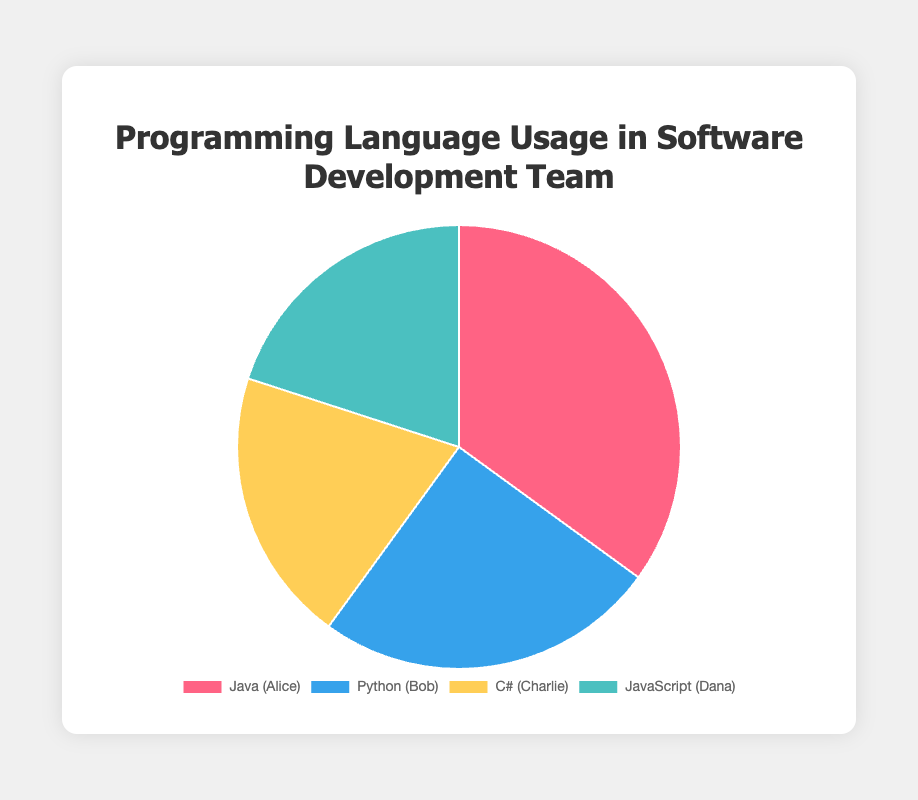Which programming language has the highest percentage usage in the team? The chart shows four segments, each representing a different programming language usage. The largest segment corresponds to Java at 35%.
Answer: Java Which two programming languages have equal usage percentages? By analyzing the pie chart, we see that the segments for C# and JavaScript both cover 20% of the chart.
Answer: C# and JavaScript How much more usage does Java have compared to Python? Java has a usage percentage of 35% while Python has 25%. Therefore, Java is used 35% - 25% = 10% more than Python.
Answer: 10% What is the sum of the usage percentages of C# and JavaScript? Both C# and JavaScript have a usage percentage of 20%. Adding these together gives 20% + 20% = 40%.
Answer: 40% Which language is represented by the green segment? The check chart colors to determine that JavaScript is represented by the green color.
Answer: JavaScript Who is associated with the language that has the second highest usage? The second highest usage percentage is Python at 25%, and Bob is associated with Python.
Answer: Bob What is the difference in usage percentages between the least used language and Python? The least used languages are C# and JavaScript at 20% each. The difference between Python's 25% and any of these two is 25% - 20% = 5%.
Answer: 5% What's the average usage percentage across all four programming languages? Sum the percentages of all languages: 35% + 25% + 20% + 20% = 100%. Divide by the number of languages: 100% / 4 = 25%.
Answer: 25% Which team member is associated with the programming language used the least? The least used languages are C# and JavaScript at 20%, associated with Charlie and Dana respectively.
Answer: Charlie and Dana 